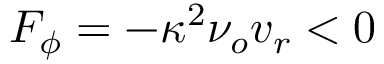Convert formula to latex. <formula><loc_0><loc_0><loc_500><loc_500>F _ { \phi } = - \kappa ^ { 2 } \nu _ { o } v _ { r } < 0</formula> 